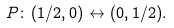Convert formula to latex. <formula><loc_0><loc_0><loc_500><loc_500>P \colon ( 1 / 2 , 0 ) \leftrightarrow ( 0 , 1 / 2 ) .</formula> 